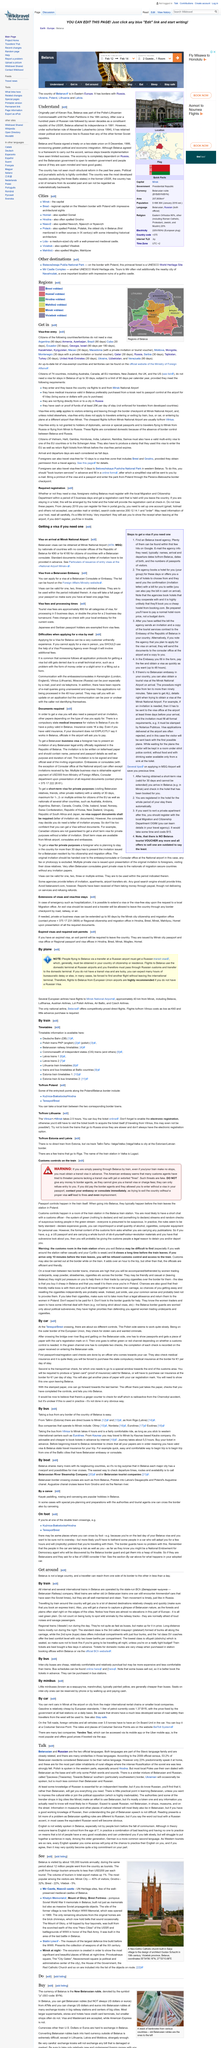Draw attention to some important aspects in this diagram. According to the 2009 official census, 53.2% of Belarusian residents identified Belarusian as their native language, reflecting a significant portion of the population's linguistic identity. The economy of the country that attained its independence in 1991 is completely dependent on Russia. A traveler can cross Belarus from one side of its border to the other in less than a day, as stated on the "Get around" page. The Belarusian state-run BCh company operates all internal and several international trains in Belarus. Mir Castle and Niasviz Castle are two of the few well-preserved medieval castles in Belarus. These castles provide a glimpse into the rich history and architecture of the region. 